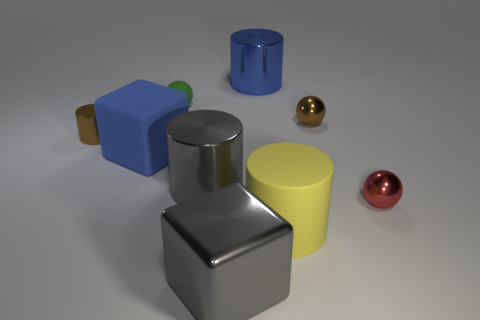Is the tiny red ball made of the same material as the tiny ball that is to the left of the matte cylinder?
Offer a very short reply. No. Are there fewer gray objects that are to the right of the big blue cube than shiny objects on the left side of the brown ball?
Offer a very short reply. Yes. How many large yellow objects have the same material as the tiny green ball?
Your response must be concise. 1. There is a tiny metal ball behind the tiny shiny ball that is in front of the blue matte cube; is there a red sphere that is on the left side of it?
Keep it short and to the point. No. How many blocks are tiny brown objects or large blue objects?
Keep it short and to the point. 1. Is the shape of the tiny green thing the same as the big metal object that is behind the blue rubber thing?
Offer a terse response. No. Is the number of blue matte objects to the left of the tiny cylinder less than the number of big yellow rubber spheres?
Provide a succinct answer. No. There is a tiny green matte thing; are there any tiny spheres left of it?
Make the answer very short. No. Are there any blue matte objects of the same shape as the red metal object?
Offer a terse response. No. There is a green rubber thing that is the same size as the red metallic object; what is its shape?
Your answer should be compact. Sphere. 